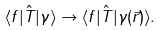Convert formula to latex. <formula><loc_0><loc_0><loc_500><loc_500>\langle f | \hat { T } | \gamma \rangle \rightarrow \langle f | \hat { T } | \gamma ( \vec { r } ) \rangle .</formula> 